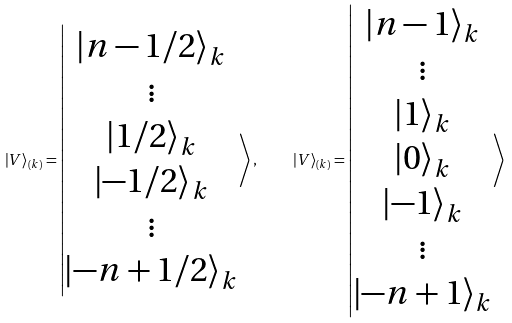<formula> <loc_0><loc_0><loc_500><loc_500>\left | V \right \rangle _ { ( k ) } = \left | \begin{matrix} \left | n - 1 / 2 \right \rangle _ { k } \\ \vdots \\ \left | 1 / 2 \right \rangle _ { k } \\ \left | - 1 / 2 \right \rangle _ { k } \\ \vdots \\ \left | - n + 1 / 2 \right \rangle _ { k } \\ \end{matrix} \right \rangle , \quad \left | V \right \rangle _ { ( k ) } = \left | \begin{matrix} \left | n - 1 \right \rangle _ { k } \\ \vdots \\ \left | 1 \right \rangle _ { k } \\ \left | 0 \right \rangle _ { k } \\ \left | - 1 \right \rangle _ { k } \\ \vdots \\ \left | - n + 1 \right \rangle _ { k } \\ \end{matrix} \right \rangle</formula> 